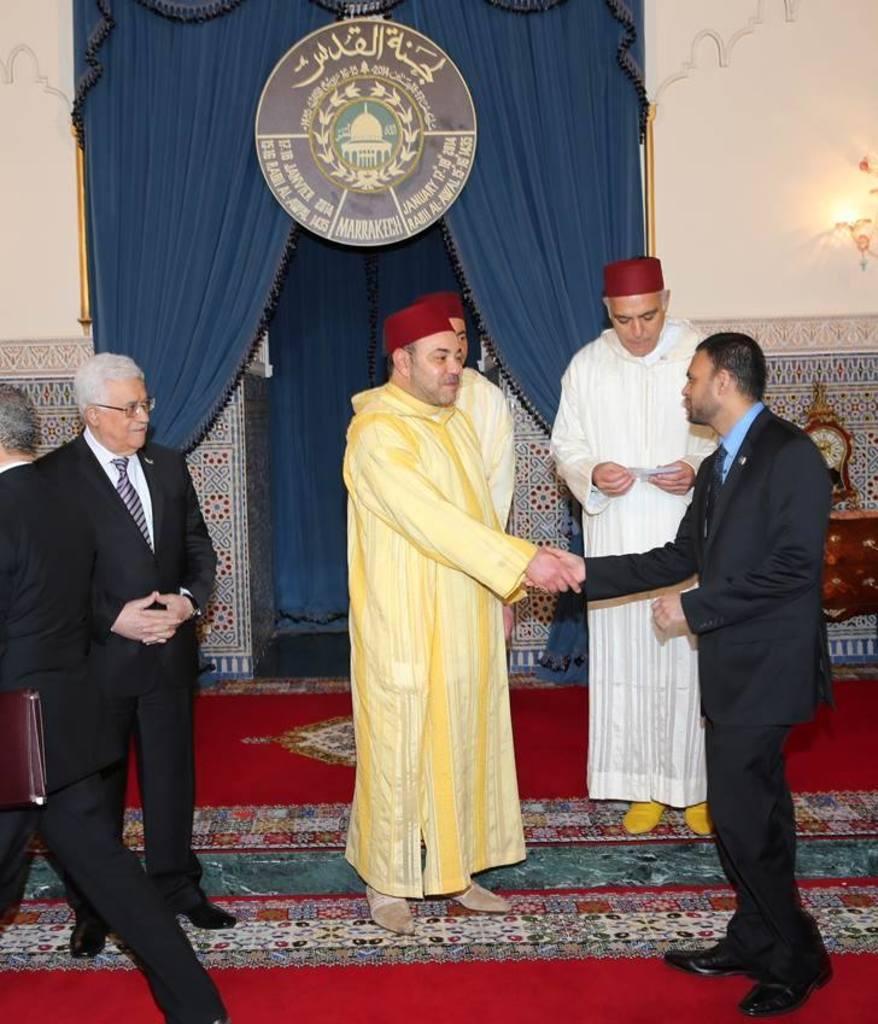In one or two sentences, can you explain what this image depicts? In the background we can see a wall, light, curtains and a board. We can see people standing on the floor. On the left side we can see a man walking. We can see this two men shaking their hands. At the bottom of the picture we can see the floor carpet. 